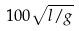<formula> <loc_0><loc_0><loc_500><loc_500>1 0 0 \sqrt { l / g }</formula> 